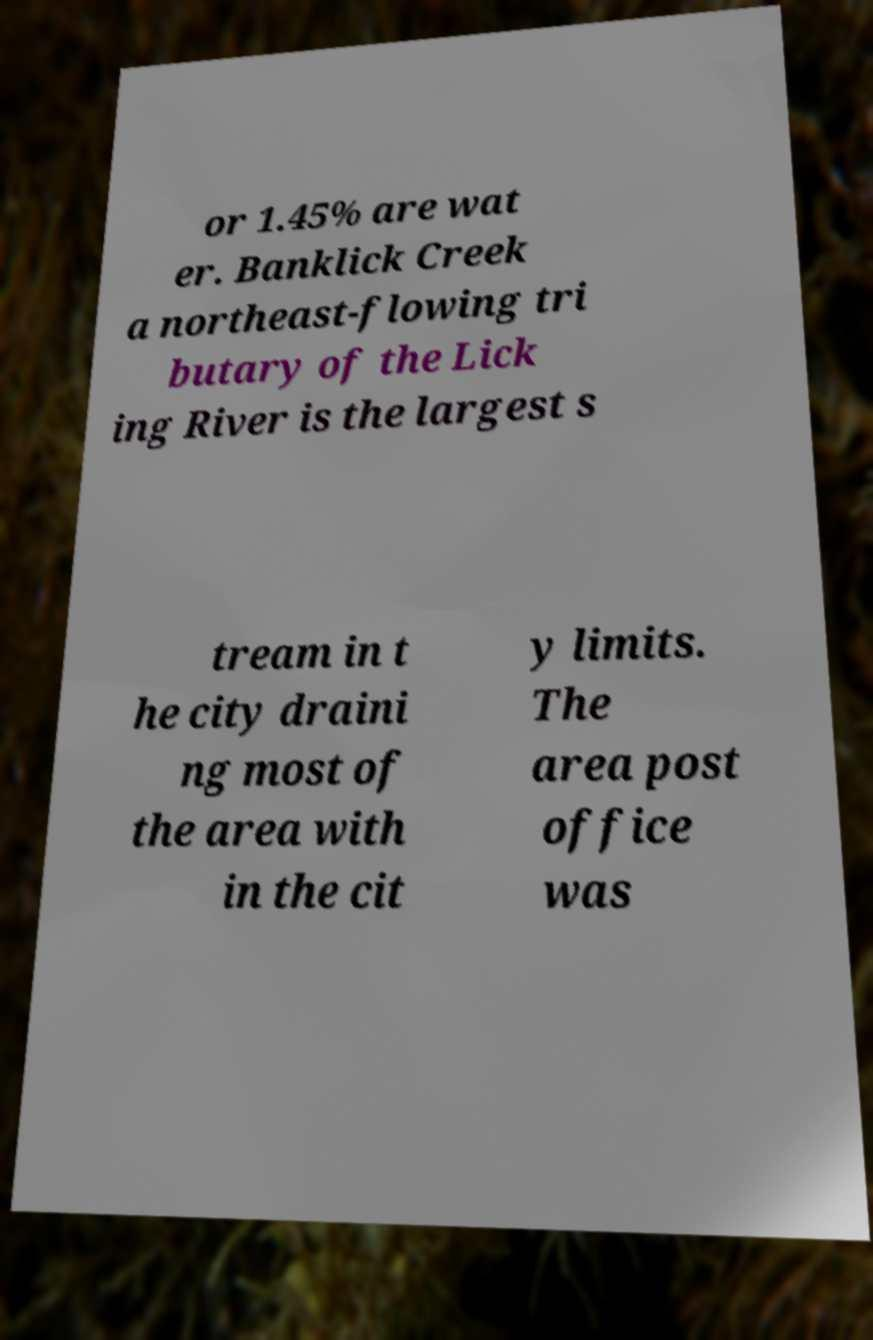Could you assist in decoding the text presented in this image and type it out clearly? or 1.45% are wat er. Banklick Creek a northeast-flowing tri butary of the Lick ing River is the largest s tream in t he city draini ng most of the area with in the cit y limits. The area post office was 